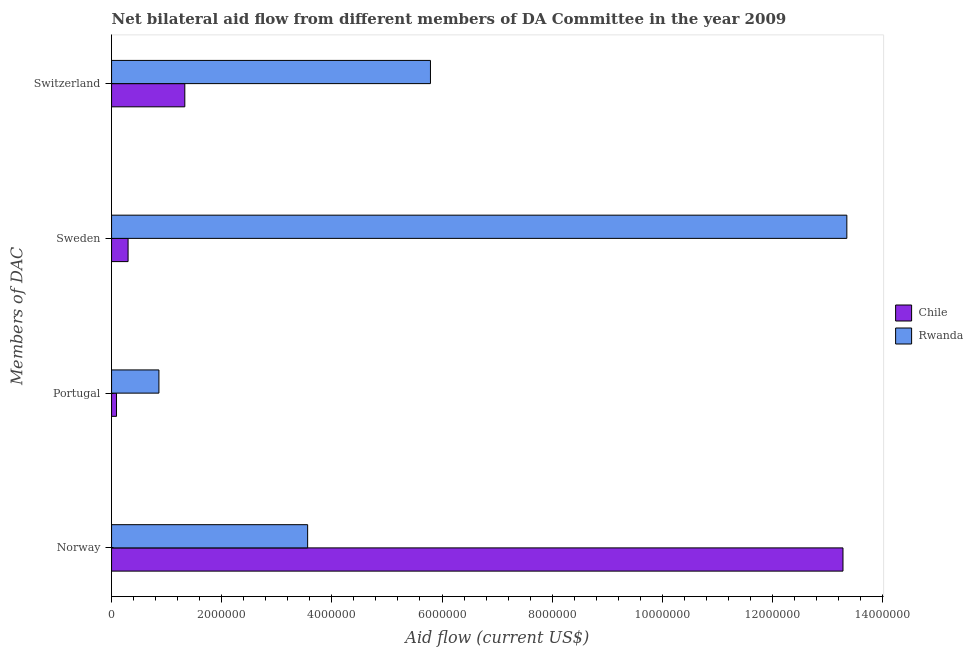How many groups of bars are there?
Make the answer very short. 4. Are the number of bars on each tick of the Y-axis equal?
Ensure brevity in your answer.  Yes. How many bars are there on the 2nd tick from the top?
Ensure brevity in your answer.  2. What is the amount of aid given by portugal in Chile?
Provide a succinct answer. 9.00e+04. Across all countries, what is the maximum amount of aid given by portugal?
Make the answer very short. 8.60e+05. Across all countries, what is the minimum amount of aid given by portugal?
Your answer should be compact. 9.00e+04. In which country was the amount of aid given by switzerland maximum?
Your answer should be compact. Rwanda. In which country was the amount of aid given by norway minimum?
Offer a terse response. Rwanda. What is the total amount of aid given by portugal in the graph?
Provide a short and direct response. 9.50e+05. What is the difference between the amount of aid given by sweden in Chile and that in Rwanda?
Make the answer very short. -1.30e+07. What is the difference between the amount of aid given by norway in Rwanda and the amount of aid given by sweden in Chile?
Offer a terse response. 3.26e+06. What is the average amount of aid given by sweden per country?
Make the answer very short. 6.82e+06. What is the difference between the amount of aid given by switzerland and amount of aid given by portugal in Rwanda?
Keep it short and to the point. 4.93e+06. What is the ratio of the amount of aid given by switzerland in Rwanda to that in Chile?
Your answer should be compact. 4.35. What is the difference between the highest and the second highest amount of aid given by switzerland?
Offer a terse response. 4.46e+06. What is the difference between the highest and the lowest amount of aid given by switzerland?
Give a very brief answer. 4.46e+06. Is the sum of the amount of aid given by portugal in Chile and Rwanda greater than the maximum amount of aid given by switzerland across all countries?
Provide a short and direct response. No. What does the 2nd bar from the top in Norway represents?
Your answer should be very brief. Chile. Is it the case that in every country, the sum of the amount of aid given by norway and amount of aid given by portugal is greater than the amount of aid given by sweden?
Your response must be concise. No. How many bars are there?
Provide a succinct answer. 8. What is the difference between two consecutive major ticks on the X-axis?
Provide a succinct answer. 2.00e+06. Are the values on the major ticks of X-axis written in scientific E-notation?
Offer a terse response. No. Does the graph contain any zero values?
Your answer should be very brief. No. Does the graph contain grids?
Your answer should be very brief. No. How are the legend labels stacked?
Provide a short and direct response. Vertical. What is the title of the graph?
Offer a terse response. Net bilateral aid flow from different members of DA Committee in the year 2009. What is the label or title of the Y-axis?
Your answer should be compact. Members of DAC. What is the Aid flow (current US$) in Chile in Norway?
Your answer should be very brief. 1.33e+07. What is the Aid flow (current US$) in Rwanda in Norway?
Offer a very short reply. 3.56e+06. What is the Aid flow (current US$) in Rwanda in Portugal?
Make the answer very short. 8.60e+05. What is the Aid flow (current US$) of Chile in Sweden?
Provide a succinct answer. 3.00e+05. What is the Aid flow (current US$) in Rwanda in Sweden?
Provide a short and direct response. 1.34e+07. What is the Aid flow (current US$) in Chile in Switzerland?
Ensure brevity in your answer.  1.33e+06. What is the Aid flow (current US$) of Rwanda in Switzerland?
Your answer should be very brief. 5.79e+06. Across all Members of DAC, what is the maximum Aid flow (current US$) in Chile?
Offer a very short reply. 1.33e+07. Across all Members of DAC, what is the maximum Aid flow (current US$) in Rwanda?
Offer a terse response. 1.34e+07. Across all Members of DAC, what is the minimum Aid flow (current US$) in Rwanda?
Ensure brevity in your answer.  8.60e+05. What is the total Aid flow (current US$) in Chile in the graph?
Make the answer very short. 1.50e+07. What is the total Aid flow (current US$) of Rwanda in the graph?
Offer a very short reply. 2.36e+07. What is the difference between the Aid flow (current US$) in Chile in Norway and that in Portugal?
Provide a succinct answer. 1.32e+07. What is the difference between the Aid flow (current US$) in Rwanda in Norway and that in Portugal?
Provide a succinct answer. 2.70e+06. What is the difference between the Aid flow (current US$) in Chile in Norway and that in Sweden?
Offer a very short reply. 1.30e+07. What is the difference between the Aid flow (current US$) in Rwanda in Norway and that in Sweden?
Ensure brevity in your answer.  -9.79e+06. What is the difference between the Aid flow (current US$) in Chile in Norway and that in Switzerland?
Give a very brief answer. 1.20e+07. What is the difference between the Aid flow (current US$) in Rwanda in Norway and that in Switzerland?
Offer a very short reply. -2.23e+06. What is the difference between the Aid flow (current US$) in Chile in Portugal and that in Sweden?
Make the answer very short. -2.10e+05. What is the difference between the Aid flow (current US$) in Rwanda in Portugal and that in Sweden?
Make the answer very short. -1.25e+07. What is the difference between the Aid flow (current US$) in Chile in Portugal and that in Switzerland?
Ensure brevity in your answer.  -1.24e+06. What is the difference between the Aid flow (current US$) in Rwanda in Portugal and that in Switzerland?
Provide a short and direct response. -4.93e+06. What is the difference between the Aid flow (current US$) in Chile in Sweden and that in Switzerland?
Keep it short and to the point. -1.03e+06. What is the difference between the Aid flow (current US$) in Rwanda in Sweden and that in Switzerland?
Your answer should be compact. 7.56e+06. What is the difference between the Aid flow (current US$) in Chile in Norway and the Aid flow (current US$) in Rwanda in Portugal?
Offer a very short reply. 1.24e+07. What is the difference between the Aid flow (current US$) of Chile in Norway and the Aid flow (current US$) of Rwanda in Switzerland?
Provide a short and direct response. 7.49e+06. What is the difference between the Aid flow (current US$) of Chile in Portugal and the Aid flow (current US$) of Rwanda in Sweden?
Your answer should be very brief. -1.33e+07. What is the difference between the Aid flow (current US$) of Chile in Portugal and the Aid flow (current US$) of Rwanda in Switzerland?
Offer a terse response. -5.70e+06. What is the difference between the Aid flow (current US$) of Chile in Sweden and the Aid flow (current US$) of Rwanda in Switzerland?
Your response must be concise. -5.49e+06. What is the average Aid flow (current US$) in Chile per Members of DAC?
Make the answer very short. 3.75e+06. What is the average Aid flow (current US$) in Rwanda per Members of DAC?
Provide a succinct answer. 5.89e+06. What is the difference between the Aid flow (current US$) of Chile and Aid flow (current US$) of Rwanda in Norway?
Offer a terse response. 9.72e+06. What is the difference between the Aid flow (current US$) in Chile and Aid flow (current US$) in Rwanda in Portugal?
Offer a terse response. -7.70e+05. What is the difference between the Aid flow (current US$) of Chile and Aid flow (current US$) of Rwanda in Sweden?
Keep it short and to the point. -1.30e+07. What is the difference between the Aid flow (current US$) of Chile and Aid flow (current US$) of Rwanda in Switzerland?
Make the answer very short. -4.46e+06. What is the ratio of the Aid flow (current US$) in Chile in Norway to that in Portugal?
Your response must be concise. 147.56. What is the ratio of the Aid flow (current US$) of Rwanda in Norway to that in Portugal?
Give a very brief answer. 4.14. What is the ratio of the Aid flow (current US$) of Chile in Norway to that in Sweden?
Provide a short and direct response. 44.27. What is the ratio of the Aid flow (current US$) in Rwanda in Norway to that in Sweden?
Offer a very short reply. 0.27. What is the ratio of the Aid flow (current US$) of Chile in Norway to that in Switzerland?
Offer a very short reply. 9.98. What is the ratio of the Aid flow (current US$) in Rwanda in Norway to that in Switzerland?
Your answer should be compact. 0.61. What is the ratio of the Aid flow (current US$) in Rwanda in Portugal to that in Sweden?
Offer a terse response. 0.06. What is the ratio of the Aid flow (current US$) of Chile in Portugal to that in Switzerland?
Provide a short and direct response. 0.07. What is the ratio of the Aid flow (current US$) in Rwanda in Portugal to that in Switzerland?
Provide a short and direct response. 0.15. What is the ratio of the Aid flow (current US$) in Chile in Sweden to that in Switzerland?
Give a very brief answer. 0.23. What is the ratio of the Aid flow (current US$) of Rwanda in Sweden to that in Switzerland?
Ensure brevity in your answer.  2.31. What is the difference between the highest and the second highest Aid flow (current US$) of Chile?
Make the answer very short. 1.20e+07. What is the difference between the highest and the second highest Aid flow (current US$) of Rwanda?
Your answer should be very brief. 7.56e+06. What is the difference between the highest and the lowest Aid flow (current US$) in Chile?
Ensure brevity in your answer.  1.32e+07. What is the difference between the highest and the lowest Aid flow (current US$) of Rwanda?
Your response must be concise. 1.25e+07. 